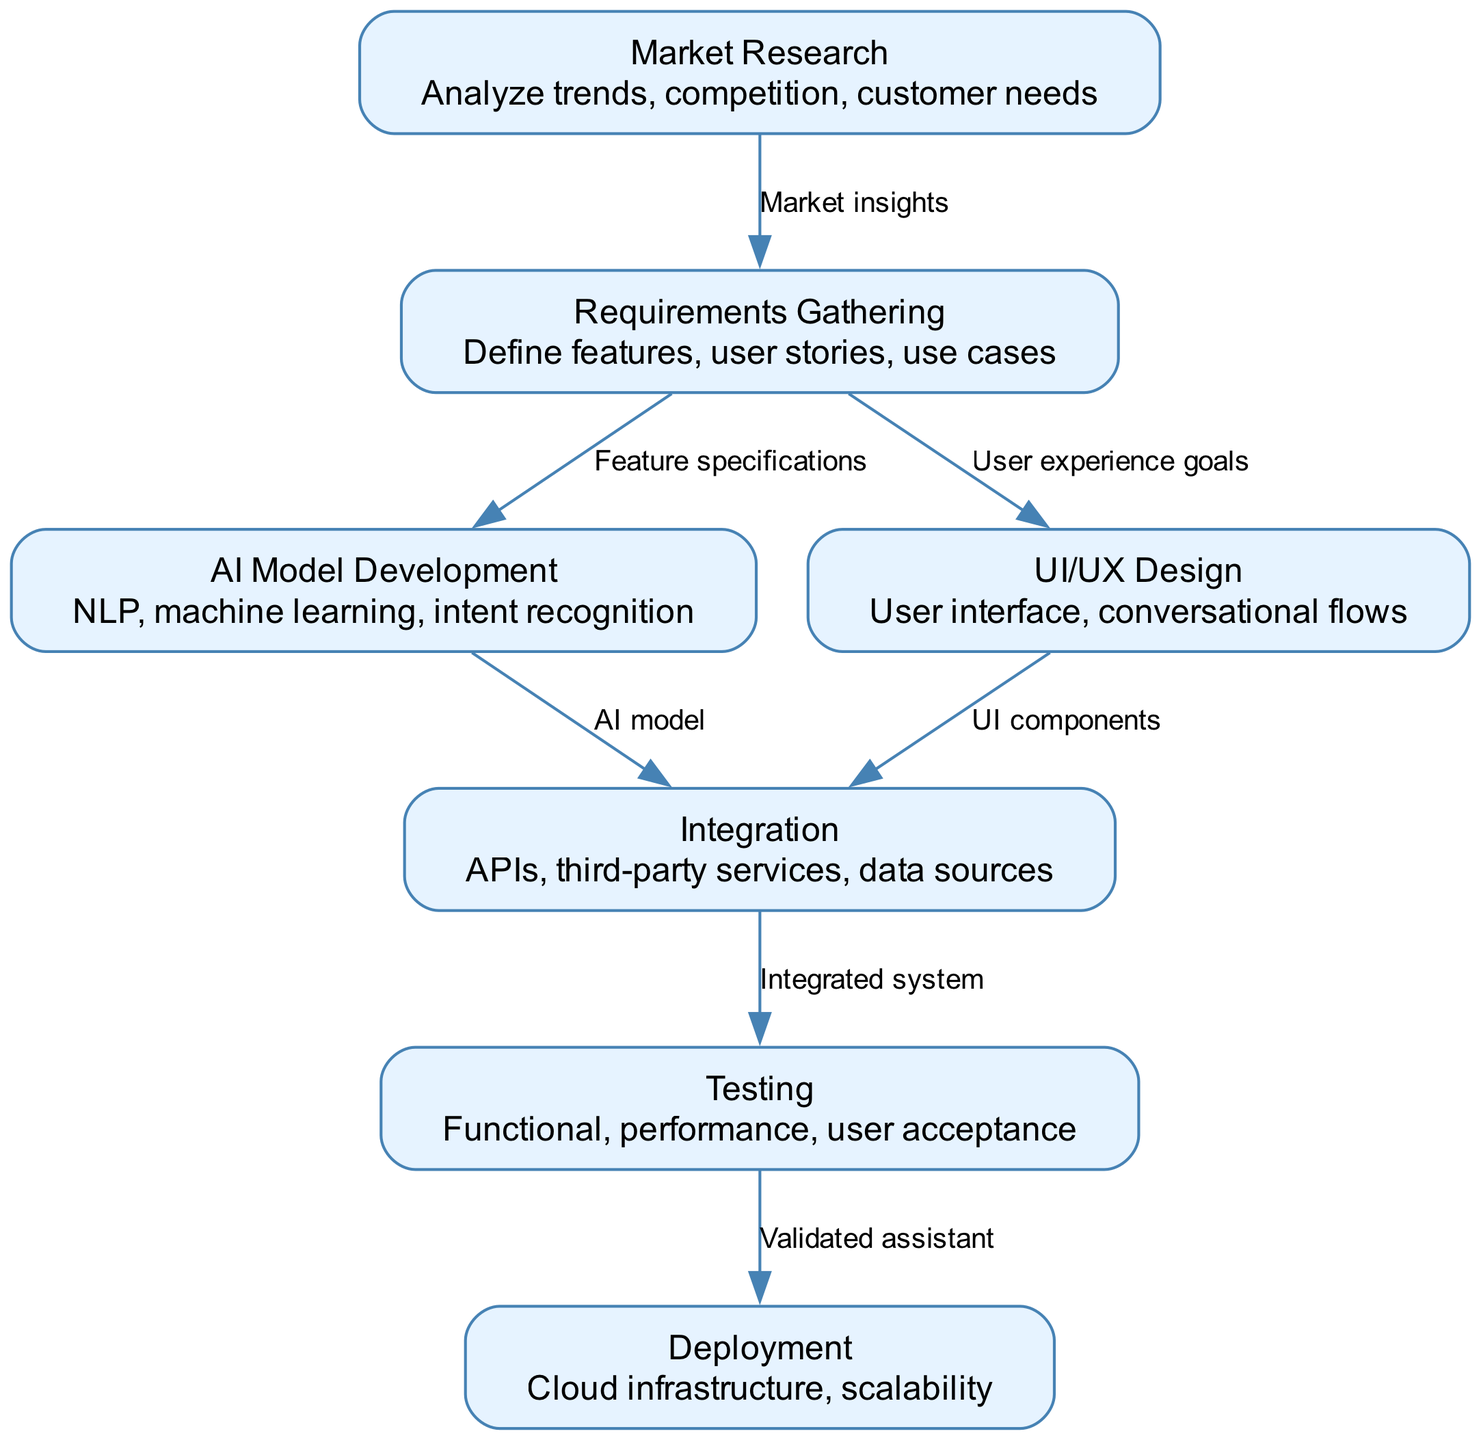What's the first node in the value stream map? The first node, labeled "Market Research," represents the initial stage of the virtual assistant development process where trends, competition, and customer needs are analyzed.
Answer: Market Research How many nodes are present in the diagram? By counting the defined nodes in the provided data, there are a total of seven nodes representing different stages of the virtual assistant development process.
Answer: 7 What relationship exists between Requirements Gathering and AI Model Development? The edge from "Requirements Gathering" to "AI Model Development" is labeled "Feature specifications," indicating that the features defined during Requirements Gathering serve as specifications for developing the AI model.
Answer: Feature specifications Which node follows the Integration node in the flow? The node that follows "Integration" in the flow is "Testing," indicating that after integration of APIs and services, the system proceeds to undergo testing.
Answer: Testing What is the final node in the value stream mapping process? The final node in the mapping process is "Deployment," which signifies the last stage where the validated assistant is deployed into a cloud infrastructure for scalability.
Answer: Deployment Which nodes are directly connected to the Requirements Gathering node? The nodes directly connected to "Requirements Gathering" are "AI Model Development" and "UI/UX Design," indicating its role in informing both features and user experience.
Answer: AI Model Development, UI/UX Design What do the edges from AI Model Development and UI/UX Design lead to? Both nodes "AI Model Development" and "UI/UX Design" lead to the "Integration" node, reflecting that both aspects contribute to the integrated system development.
Answer: Integration What is the purpose of the Testing node? The purpose of the "Testing" node is to perform various tests, including functional, performance, and user acceptance tests on the integrated system to ensure it meets requirements.
Answer: Validate assistant What insights drive the Market Research node? The Market Research node is driven by market insights, which provide a foundation for gathering requirements and defining what the product needs to achieve based on customer needs and competition.
Answer: Market insights 